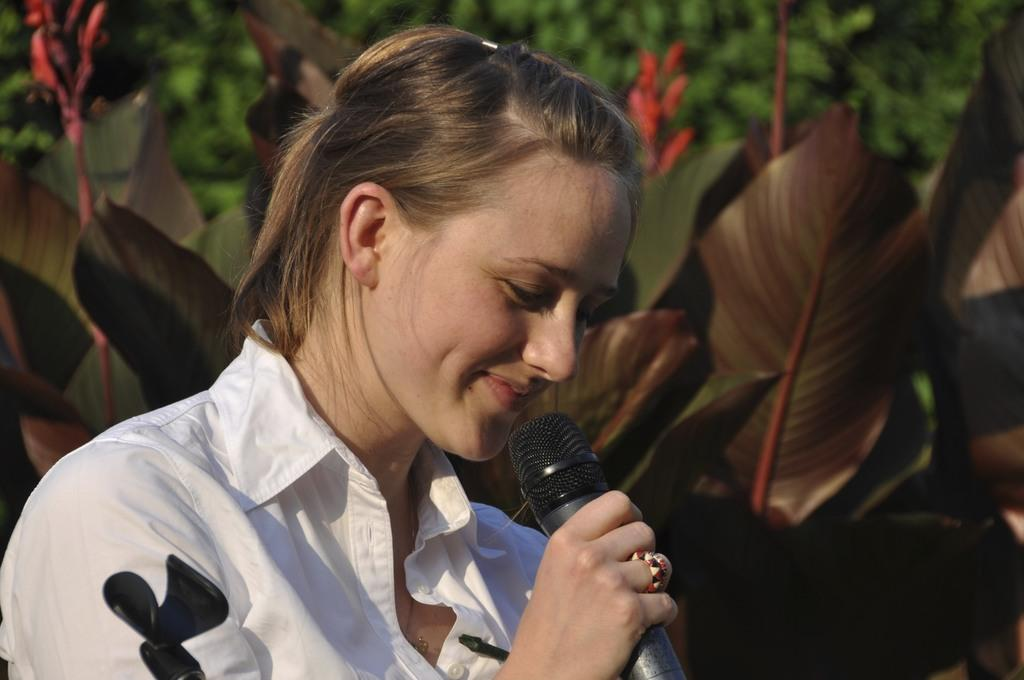Who is the main subject in the image? There is a woman in the image. What is the woman holding in her right hand? The woman is holding a microphone in her right hand. What is the woman's facial expression in the image? The woman is smiling. What can be seen in the background of the image? There are plants in the background of the image. Can you hear the bells ringing in the image? There are no bells present in the image, so it is not possible to hear them ringing. 